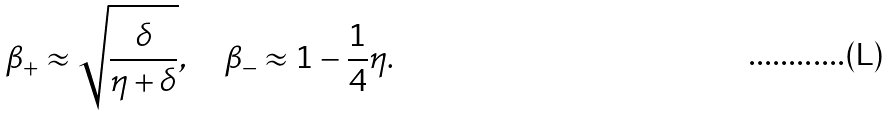Convert formula to latex. <formula><loc_0><loc_0><loc_500><loc_500>\beta _ { + } \approx \sqrt { \frac { \delta } { \eta + \delta } } , \quad \beta _ { - } \approx 1 - { \frac { 1 } { 4 } } \eta .</formula> 